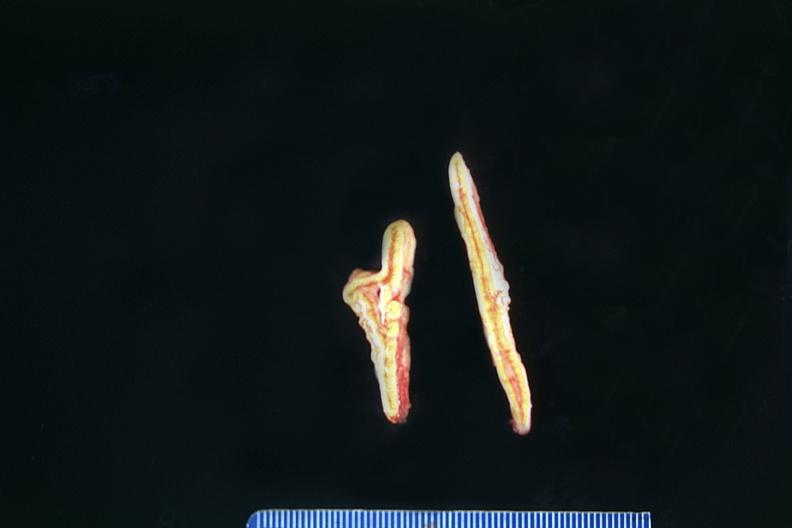does this image show adrenals, normal?
Answer the question using a single word or phrase. Yes 